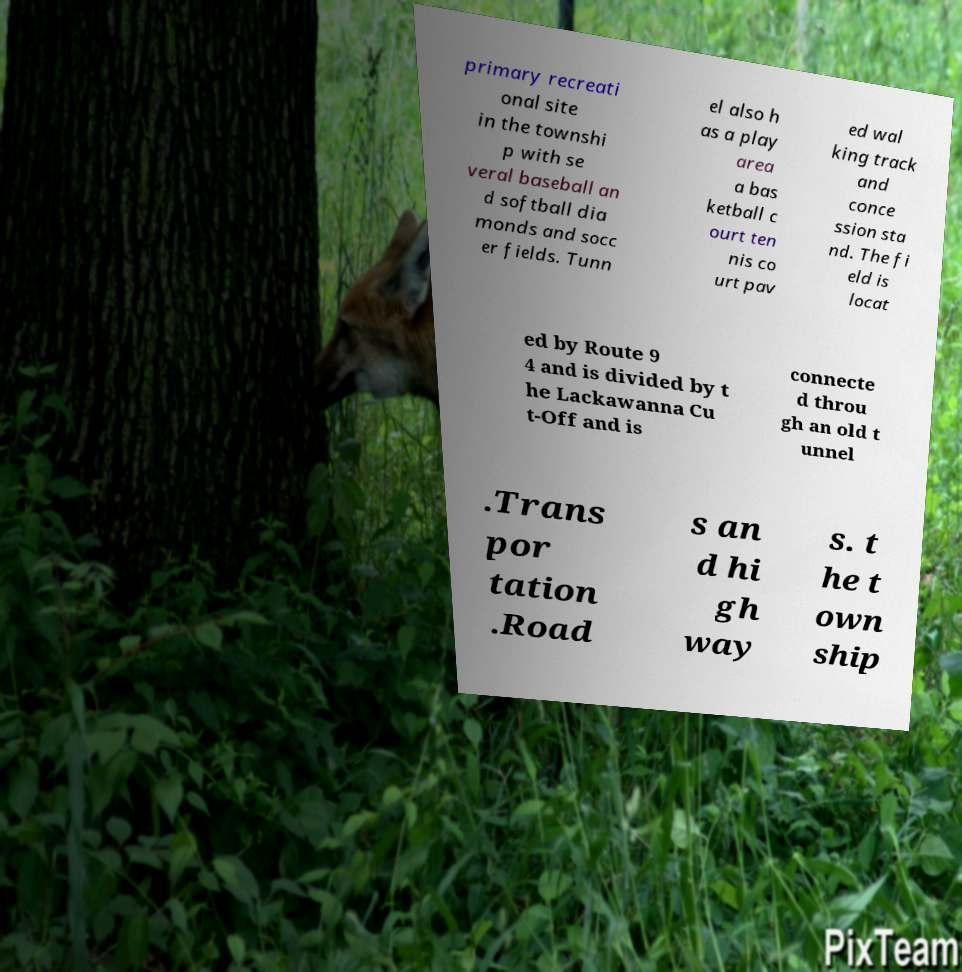Could you assist in decoding the text presented in this image and type it out clearly? primary recreati onal site in the townshi p with se veral baseball an d softball dia monds and socc er fields. Tunn el also h as a play area a bas ketball c ourt ten nis co urt pav ed wal king track and conce ssion sta nd. The fi eld is locat ed by Route 9 4 and is divided by t he Lackawanna Cu t-Off and is connecte d throu gh an old t unnel .Trans por tation .Road s an d hi gh way s. t he t own ship 